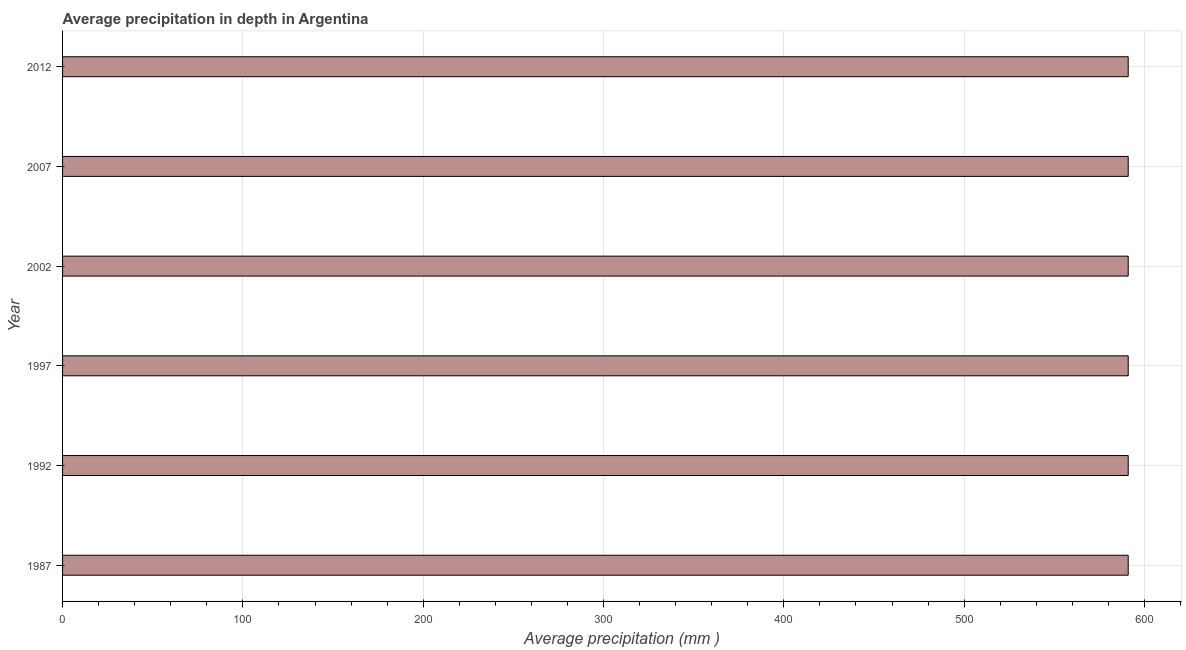What is the title of the graph?
Provide a short and direct response. Average precipitation in depth in Argentina. What is the label or title of the X-axis?
Your answer should be very brief. Average precipitation (mm ). What is the label or title of the Y-axis?
Offer a terse response. Year. What is the average precipitation in depth in 1987?
Keep it short and to the point. 591. Across all years, what is the maximum average precipitation in depth?
Make the answer very short. 591. Across all years, what is the minimum average precipitation in depth?
Keep it short and to the point. 591. What is the sum of the average precipitation in depth?
Offer a very short reply. 3546. What is the difference between the average precipitation in depth in 1997 and 2012?
Offer a terse response. 0. What is the average average precipitation in depth per year?
Provide a succinct answer. 591. What is the median average precipitation in depth?
Your answer should be compact. 591. In how many years, is the average precipitation in depth greater than 560 mm?
Your answer should be compact. 6. In how many years, is the average precipitation in depth greater than the average average precipitation in depth taken over all years?
Make the answer very short. 0. How many bars are there?
Make the answer very short. 6. How many years are there in the graph?
Ensure brevity in your answer.  6. What is the Average precipitation (mm ) in 1987?
Keep it short and to the point. 591. What is the Average precipitation (mm ) in 1992?
Your answer should be very brief. 591. What is the Average precipitation (mm ) in 1997?
Keep it short and to the point. 591. What is the Average precipitation (mm ) of 2002?
Give a very brief answer. 591. What is the Average precipitation (mm ) in 2007?
Offer a very short reply. 591. What is the Average precipitation (mm ) of 2012?
Ensure brevity in your answer.  591. What is the difference between the Average precipitation (mm ) in 1987 and 2012?
Offer a terse response. 0. What is the difference between the Average precipitation (mm ) in 1992 and 1997?
Offer a very short reply. 0. What is the difference between the Average precipitation (mm ) in 1992 and 2002?
Give a very brief answer. 0. What is the difference between the Average precipitation (mm ) in 1992 and 2012?
Provide a short and direct response. 0. What is the difference between the Average precipitation (mm ) in 1997 and 2012?
Offer a terse response. 0. What is the ratio of the Average precipitation (mm ) in 1987 to that in 1992?
Give a very brief answer. 1. What is the ratio of the Average precipitation (mm ) in 1987 to that in 1997?
Your answer should be very brief. 1. What is the ratio of the Average precipitation (mm ) in 1992 to that in 2012?
Ensure brevity in your answer.  1. What is the ratio of the Average precipitation (mm ) in 1997 to that in 2002?
Offer a terse response. 1. What is the ratio of the Average precipitation (mm ) in 2007 to that in 2012?
Provide a short and direct response. 1. 